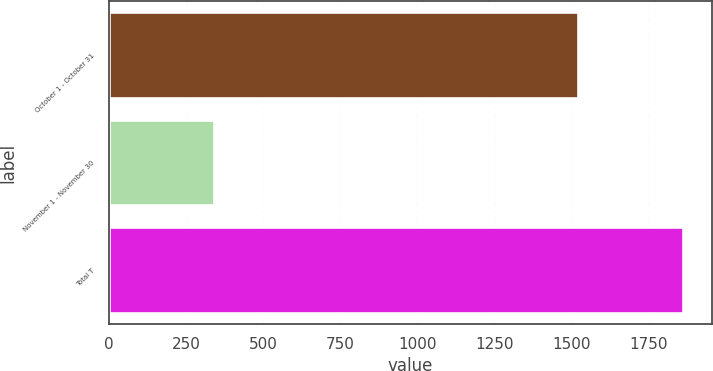Convert chart. <chart><loc_0><loc_0><loc_500><loc_500><bar_chart><fcel>October 1 - October 31<fcel>November 1 - November 30<fcel>Total T<nl><fcel>1522<fcel>341<fcel>1863<nl></chart> 